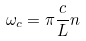Convert formula to latex. <formula><loc_0><loc_0><loc_500><loc_500>\omega _ { c } = \pi \frac { c } { L } n</formula> 